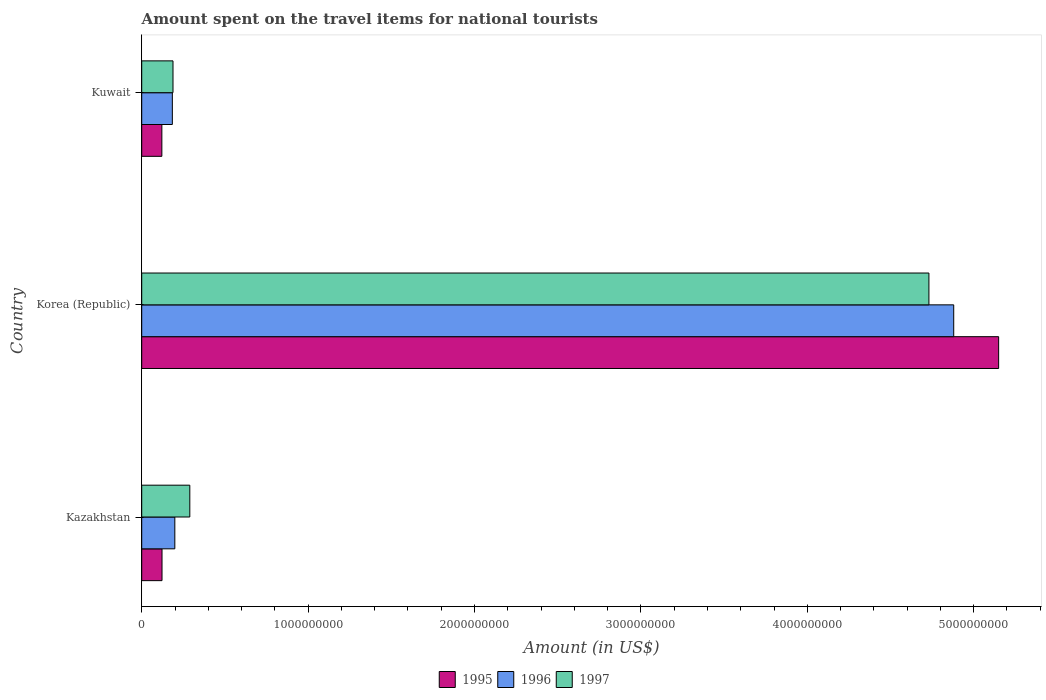How many different coloured bars are there?
Your answer should be compact. 3. Are the number of bars per tick equal to the number of legend labels?
Keep it short and to the point. Yes. Are the number of bars on each tick of the Y-axis equal?
Your answer should be compact. Yes. How many bars are there on the 1st tick from the top?
Keep it short and to the point. 3. What is the label of the 3rd group of bars from the top?
Give a very brief answer. Kazakhstan. In how many cases, is the number of bars for a given country not equal to the number of legend labels?
Keep it short and to the point. 0. What is the amount spent on the travel items for national tourists in 1996 in Kuwait?
Offer a terse response. 1.84e+08. Across all countries, what is the maximum amount spent on the travel items for national tourists in 1997?
Provide a succinct answer. 4.73e+09. Across all countries, what is the minimum amount spent on the travel items for national tourists in 1997?
Offer a terse response. 1.88e+08. In which country was the amount spent on the travel items for national tourists in 1996 maximum?
Offer a very short reply. Korea (Republic). In which country was the amount spent on the travel items for national tourists in 1996 minimum?
Keep it short and to the point. Kuwait. What is the total amount spent on the travel items for national tourists in 1995 in the graph?
Your response must be concise. 5.39e+09. What is the difference between the amount spent on the travel items for national tourists in 1995 in Kazakhstan and that in Kuwait?
Your response must be concise. 1.00e+06. What is the difference between the amount spent on the travel items for national tourists in 1997 in Kazakhstan and the amount spent on the travel items for national tourists in 1996 in Korea (Republic)?
Your response must be concise. -4.59e+09. What is the average amount spent on the travel items for national tourists in 1997 per country?
Keep it short and to the point. 1.74e+09. What is the difference between the amount spent on the travel items for national tourists in 1995 and amount spent on the travel items for national tourists in 1996 in Kuwait?
Provide a succinct answer. -6.30e+07. What is the ratio of the amount spent on the travel items for national tourists in 1995 in Kazakhstan to that in Korea (Republic)?
Your response must be concise. 0.02. Is the difference between the amount spent on the travel items for national tourists in 1995 in Kazakhstan and Korea (Republic) greater than the difference between the amount spent on the travel items for national tourists in 1996 in Kazakhstan and Korea (Republic)?
Offer a terse response. No. What is the difference between the highest and the second highest amount spent on the travel items for national tourists in 1997?
Give a very brief answer. 4.44e+09. What is the difference between the highest and the lowest amount spent on the travel items for national tourists in 1997?
Ensure brevity in your answer.  4.54e+09. In how many countries, is the amount spent on the travel items for national tourists in 1996 greater than the average amount spent on the travel items for national tourists in 1996 taken over all countries?
Provide a succinct answer. 1. What does the 3rd bar from the top in Kazakhstan represents?
Your answer should be very brief. 1995. What does the 1st bar from the bottom in Kuwait represents?
Give a very brief answer. 1995. Is it the case that in every country, the sum of the amount spent on the travel items for national tourists in 1997 and amount spent on the travel items for national tourists in 1995 is greater than the amount spent on the travel items for national tourists in 1996?
Your answer should be compact. Yes. Are the values on the major ticks of X-axis written in scientific E-notation?
Provide a short and direct response. No. Does the graph contain grids?
Your answer should be very brief. No. Where does the legend appear in the graph?
Ensure brevity in your answer.  Bottom center. How are the legend labels stacked?
Provide a short and direct response. Horizontal. What is the title of the graph?
Keep it short and to the point. Amount spent on the travel items for national tourists. Does "1971" appear as one of the legend labels in the graph?
Provide a short and direct response. No. What is the label or title of the Y-axis?
Give a very brief answer. Country. What is the Amount (in US$) in 1995 in Kazakhstan?
Your answer should be very brief. 1.22e+08. What is the Amount (in US$) of 1996 in Kazakhstan?
Your response must be concise. 1.99e+08. What is the Amount (in US$) in 1997 in Kazakhstan?
Offer a terse response. 2.89e+08. What is the Amount (in US$) of 1995 in Korea (Republic)?
Provide a short and direct response. 5.15e+09. What is the Amount (in US$) of 1996 in Korea (Republic)?
Offer a terse response. 4.88e+09. What is the Amount (in US$) in 1997 in Korea (Republic)?
Keep it short and to the point. 4.73e+09. What is the Amount (in US$) in 1995 in Kuwait?
Offer a terse response. 1.21e+08. What is the Amount (in US$) in 1996 in Kuwait?
Make the answer very short. 1.84e+08. What is the Amount (in US$) in 1997 in Kuwait?
Your answer should be very brief. 1.88e+08. Across all countries, what is the maximum Amount (in US$) in 1995?
Offer a terse response. 5.15e+09. Across all countries, what is the maximum Amount (in US$) of 1996?
Your answer should be compact. 4.88e+09. Across all countries, what is the maximum Amount (in US$) in 1997?
Your response must be concise. 4.73e+09. Across all countries, what is the minimum Amount (in US$) in 1995?
Your response must be concise. 1.21e+08. Across all countries, what is the minimum Amount (in US$) in 1996?
Provide a succinct answer. 1.84e+08. Across all countries, what is the minimum Amount (in US$) of 1997?
Your answer should be very brief. 1.88e+08. What is the total Amount (in US$) of 1995 in the graph?
Ensure brevity in your answer.  5.39e+09. What is the total Amount (in US$) in 1996 in the graph?
Provide a succinct answer. 5.26e+09. What is the total Amount (in US$) in 1997 in the graph?
Keep it short and to the point. 5.21e+09. What is the difference between the Amount (in US$) in 1995 in Kazakhstan and that in Korea (Republic)?
Your answer should be very brief. -5.03e+09. What is the difference between the Amount (in US$) in 1996 in Kazakhstan and that in Korea (Republic)?
Provide a succinct answer. -4.68e+09. What is the difference between the Amount (in US$) of 1997 in Kazakhstan and that in Korea (Republic)?
Give a very brief answer. -4.44e+09. What is the difference between the Amount (in US$) of 1995 in Kazakhstan and that in Kuwait?
Keep it short and to the point. 1.00e+06. What is the difference between the Amount (in US$) of 1996 in Kazakhstan and that in Kuwait?
Offer a terse response. 1.50e+07. What is the difference between the Amount (in US$) of 1997 in Kazakhstan and that in Kuwait?
Offer a terse response. 1.01e+08. What is the difference between the Amount (in US$) of 1995 in Korea (Republic) and that in Kuwait?
Your answer should be compact. 5.03e+09. What is the difference between the Amount (in US$) of 1996 in Korea (Republic) and that in Kuwait?
Give a very brief answer. 4.70e+09. What is the difference between the Amount (in US$) in 1997 in Korea (Republic) and that in Kuwait?
Provide a short and direct response. 4.54e+09. What is the difference between the Amount (in US$) of 1995 in Kazakhstan and the Amount (in US$) of 1996 in Korea (Republic)?
Provide a succinct answer. -4.76e+09. What is the difference between the Amount (in US$) in 1995 in Kazakhstan and the Amount (in US$) in 1997 in Korea (Republic)?
Provide a succinct answer. -4.61e+09. What is the difference between the Amount (in US$) in 1996 in Kazakhstan and the Amount (in US$) in 1997 in Korea (Republic)?
Provide a short and direct response. -4.53e+09. What is the difference between the Amount (in US$) in 1995 in Kazakhstan and the Amount (in US$) in 1996 in Kuwait?
Make the answer very short. -6.20e+07. What is the difference between the Amount (in US$) in 1995 in Kazakhstan and the Amount (in US$) in 1997 in Kuwait?
Make the answer very short. -6.60e+07. What is the difference between the Amount (in US$) of 1996 in Kazakhstan and the Amount (in US$) of 1997 in Kuwait?
Offer a terse response. 1.10e+07. What is the difference between the Amount (in US$) in 1995 in Korea (Republic) and the Amount (in US$) in 1996 in Kuwait?
Your answer should be very brief. 4.97e+09. What is the difference between the Amount (in US$) in 1995 in Korea (Republic) and the Amount (in US$) in 1997 in Kuwait?
Your answer should be compact. 4.96e+09. What is the difference between the Amount (in US$) in 1996 in Korea (Republic) and the Amount (in US$) in 1997 in Kuwait?
Give a very brief answer. 4.69e+09. What is the average Amount (in US$) in 1995 per country?
Offer a terse response. 1.80e+09. What is the average Amount (in US$) of 1996 per country?
Your answer should be very brief. 1.75e+09. What is the average Amount (in US$) of 1997 per country?
Your answer should be compact. 1.74e+09. What is the difference between the Amount (in US$) of 1995 and Amount (in US$) of 1996 in Kazakhstan?
Your answer should be very brief. -7.70e+07. What is the difference between the Amount (in US$) of 1995 and Amount (in US$) of 1997 in Kazakhstan?
Offer a very short reply. -1.67e+08. What is the difference between the Amount (in US$) in 1996 and Amount (in US$) in 1997 in Kazakhstan?
Keep it short and to the point. -9.00e+07. What is the difference between the Amount (in US$) of 1995 and Amount (in US$) of 1996 in Korea (Republic)?
Give a very brief answer. 2.70e+08. What is the difference between the Amount (in US$) of 1995 and Amount (in US$) of 1997 in Korea (Republic)?
Offer a terse response. 4.19e+08. What is the difference between the Amount (in US$) in 1996 and Amount (in US$) in 1997 in Korea (Republic)?
Provide a short and direct response. 1.49e+08. What is the difference between the Amount (in US$) of 1995 and Amount (in US$) of 1996 in Kuwait?
Give a very brief answer. -6.30e+07. What is the difference between the Amount (in US$) in 1995 and Amount (in US$) in 1997 in Kuwait?
Give a very brief answer. -6.70e+07. What is the difference between the Amount (in US$) in 1996 and Amount (in US$) in 1997 in Kuwait?
Offer a terse response. -4.00e+06. What is the ratio of the Amount (in US$) in 1995 in Kazakhstan to that in Korea (Republic)?
Keep it short and to the point. 0.02. What is the ratio of the Amount (in US$) in 1996 in Kazakhstan to that in Korea (Republic)?
Offer a terse response. 0.04. What is the ratio of the Amount (in US$) of 1997 in Kazakhstan to that in Korea (Republic)?
Provide a short and direct response. 0.06. What is the ratio of the Amount (in US$) of 1995 in Kazakhstan to that in Kuwait?
Offer a terse response. 1.01. What is the ratio of the Amount (in US$) in 1996 in Kazakhstan to that in Kuwait?
Keep it short and to the point. 1.08. What is the ratio of the Amount (in US$) of 1997 in Kazakhstan to that in Kuwait?
Ensure brevity in your answer.  1.54. What is the ratio of the Amount (in US$) in 1995 in Korea (Republic) to that in Kuwait?
Ensure brevity in your answer.  42.56. What is the ratio of the Amount (in US$) in 1996 in Korea (Republic) to that in Kuwait?
Make the answer very short. 26.52. What is the ratio of the Amount (in US$) in 1997 in Korea (Republic) to that in Kuwait?
Give a very brief answer. 25.16. What is the difference between the highest and the second highest Amount (in US$) in 1995?
Offer a very short reply. 5.03e+09. What is the difference between the highest and the second highest Amount (in US$) of 1996?
Offer a very short reply. 4.68e+09. What is the difference between the highest and the second highest Amount (in US$) in 1997?
Offer a very short reply. 4.44e+09. What is the difference between the highest and the lowest Amount (in US$) in 1995?
Provide a short and direct response. 5.03e+09. What is the difference between the highest and the lowest Amount (in US$) in 1996?
Give a very brief answer. 4.70e+09. What is the difference between the highest and the lowest Amount (in US$) of 1997?
Your answer should be very brief. 4.54e+09. 